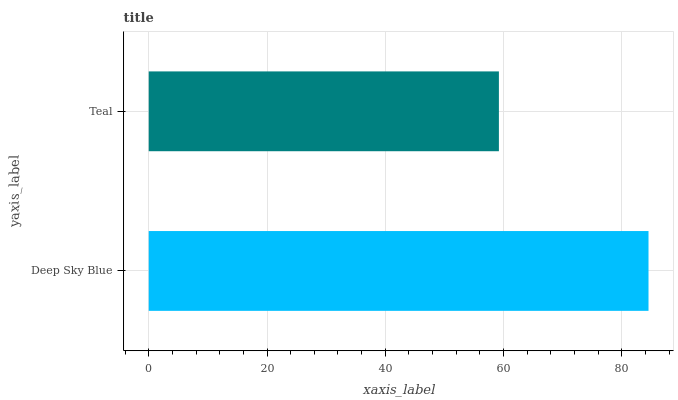Is Teal the minimum?
Answer yes or no. Yes. Is Deep Sky Blue the maximum?
Answer yes or no. Yes. Is Teal the maximum?
Answer yes or no. No. Is Deep Sky Blue greater than Teal?
Answer yes or no. Yes. Is Teal less than Deep Sky Blue?
Answer yes or no. Yes. Is Teal greater than Deep Sky Blue?
Answer yes or no. No. Is Deep Sky Blue less than Teal?
Answer yes or no. No. Is Deep Sky Blue the high median?
Answer yes or no. Yes. Is Teal the low median?
Answer yes or no. Yes. Is Teal the high median?
Answer yes or no. No. Is Deep Sky Blue the low median?
Answer yes or no. No. 